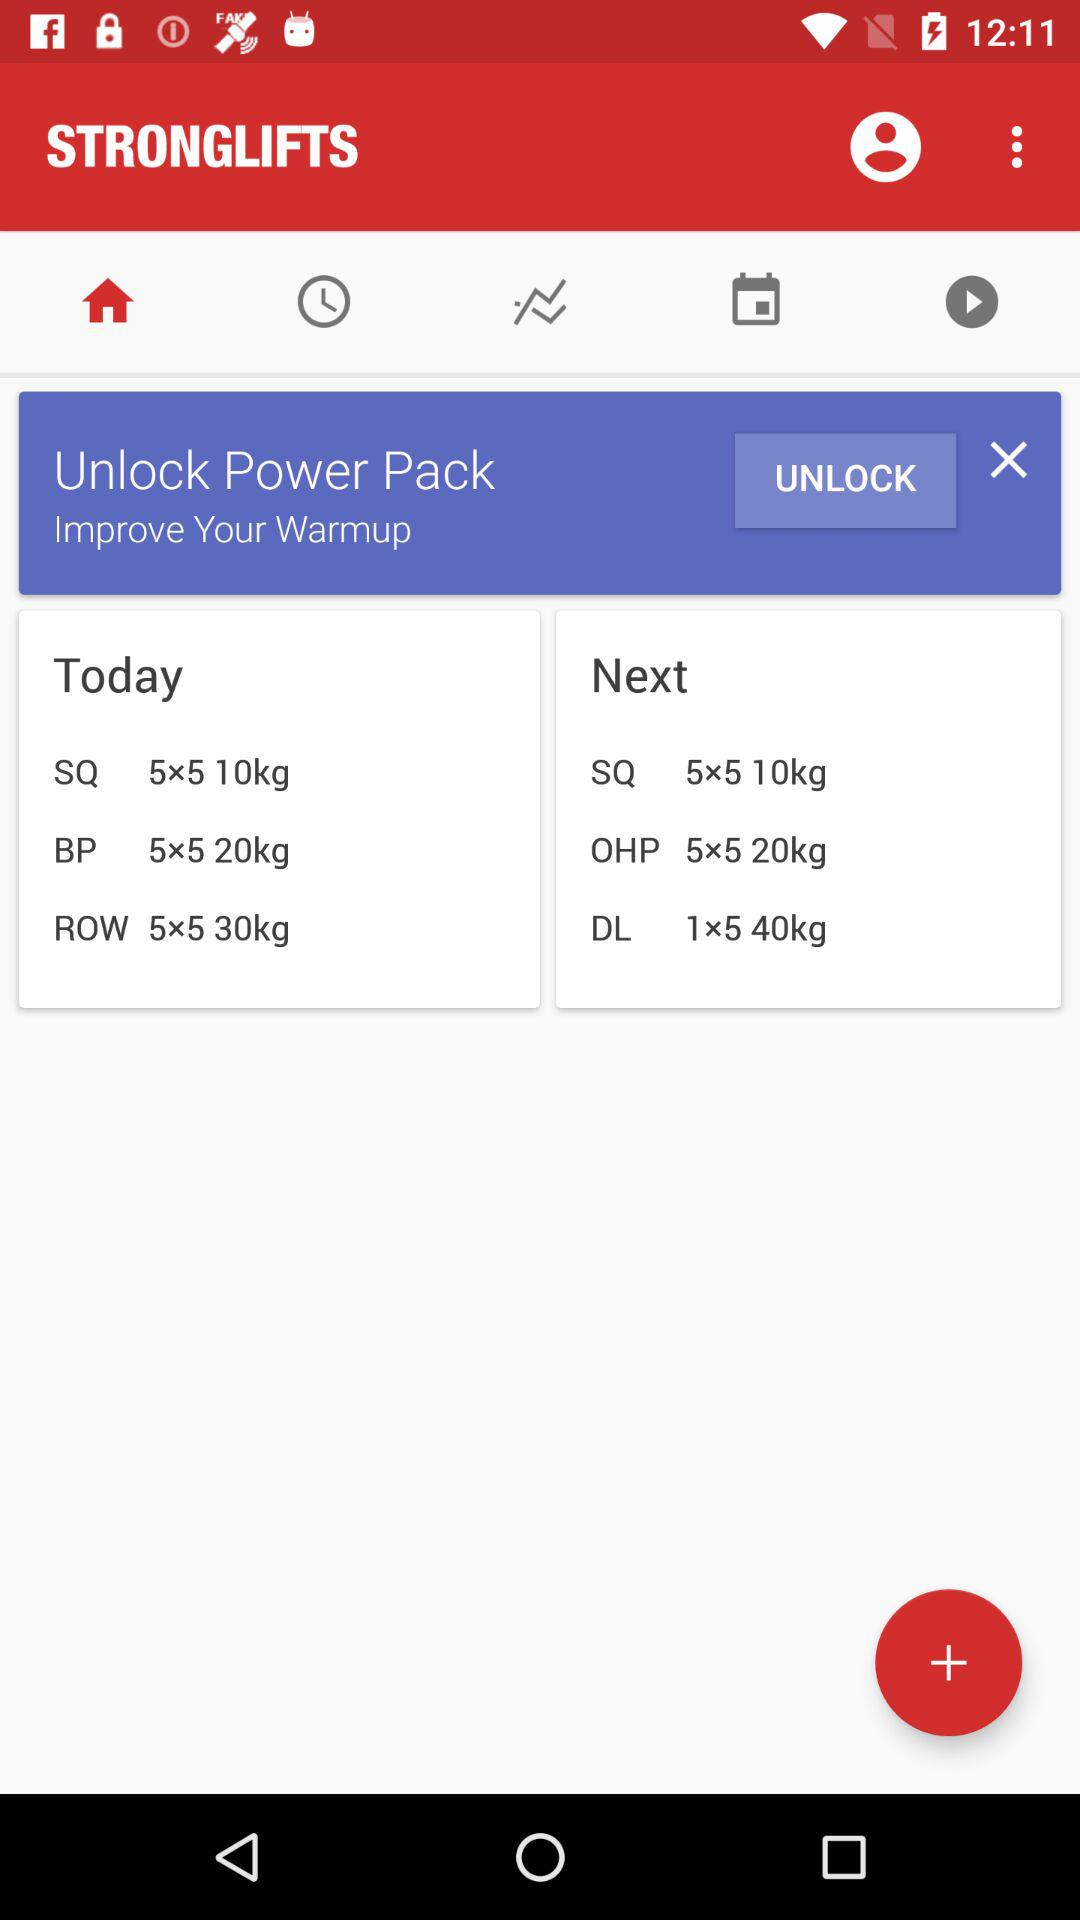What is the application name? The application name is "STRONGLIFTS". 